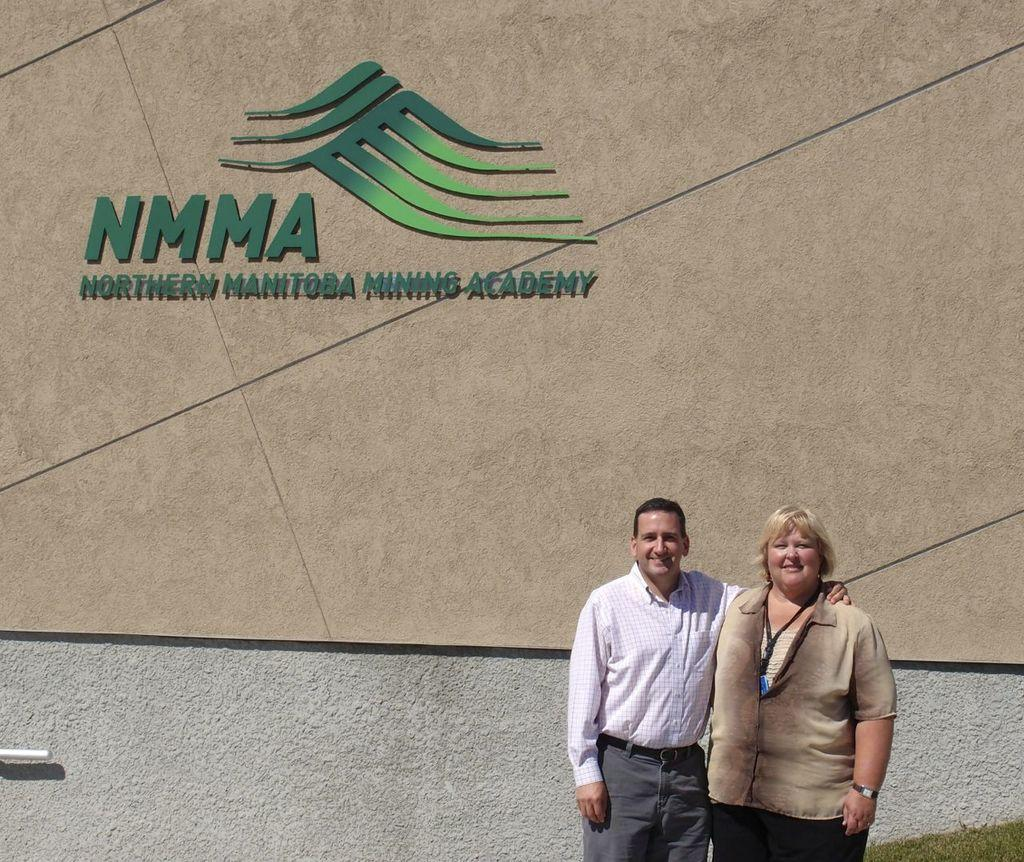How many people are present in the image? There are two people standing in the image. What can be seen in the background of the image? There is a wall in the background of the image. What is on the wall? The wall has a logo on it and something written on it. What type of apple can be seen crushing the moon in the image? There is no apple or moon present in the image; it only features two people and a wall with a logo and writing. 